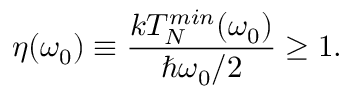<formula> <loc_0><loc_0><loc_500><loc_500>\eta ( \omega _ { 0 } ) \equiv \frac { k T _ { N } ^ { \min } ( \omega _ { 0 } ) } { \hbar { \omega } _ { 0 } / 2 } \geq 1 .</formula> 